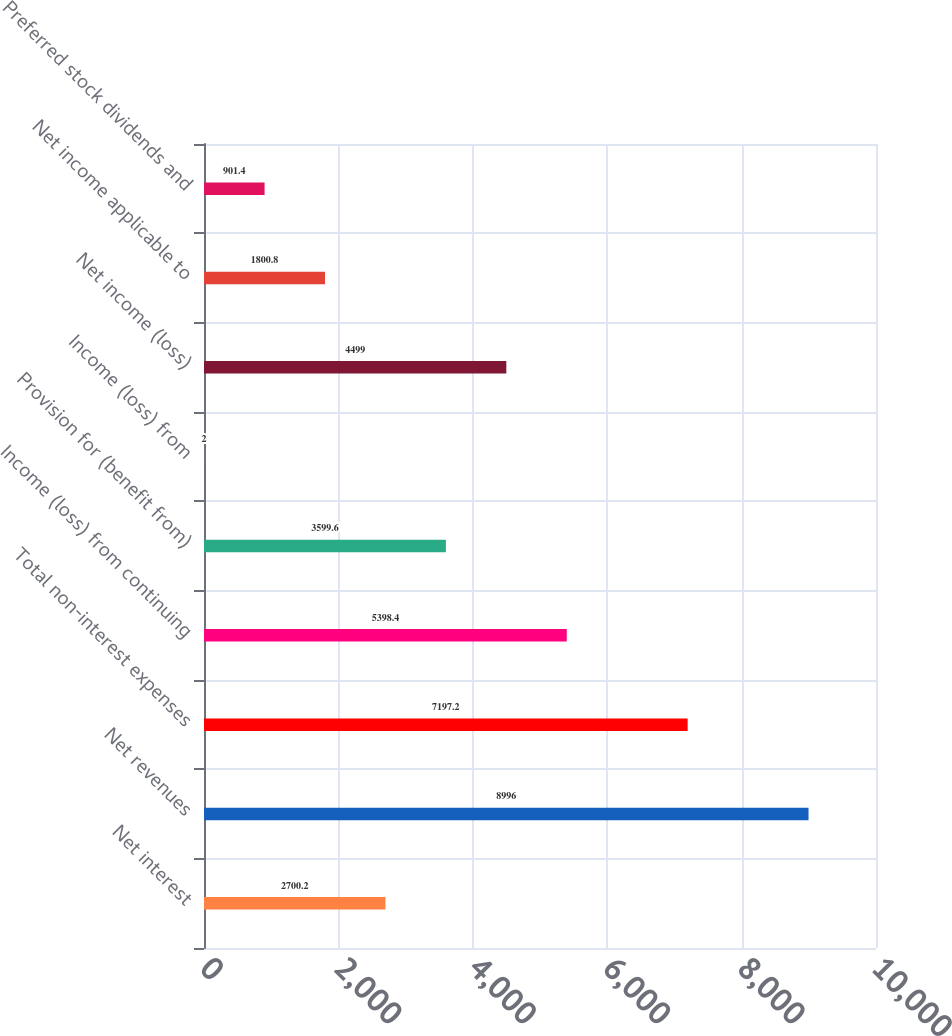<chart> <loc_0><loc_0><loc_500><loc_500><bar_chart><fcel>Net interest<fcel>Net revenues<fcel>Total non-interest expenses<fcel>Income (loss) from continuing<fcel>Provision for (benefit from)<fcel>Income (loss) from<fcel>Net income (loss)<fcel>Net income applicable to<fcel>Preferred stock dividends and<nl><fcel>2700.2<fcel>8996<fcel>7197.2<fcel>5398.4<fcel>3599.6<fcel>2<fcel>4499<fcel>1800.8<fcel>901.4<nl></chart> 